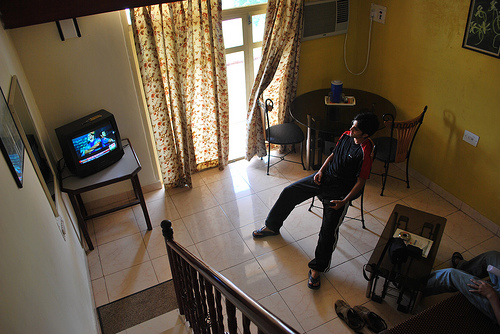How many people are in the image? There are two people visible in the image. One person seems to be standing and watching television, and the other is sitting with their back to the camera, creating a relaxed and casual atmosphere in what appears to be a living room. 